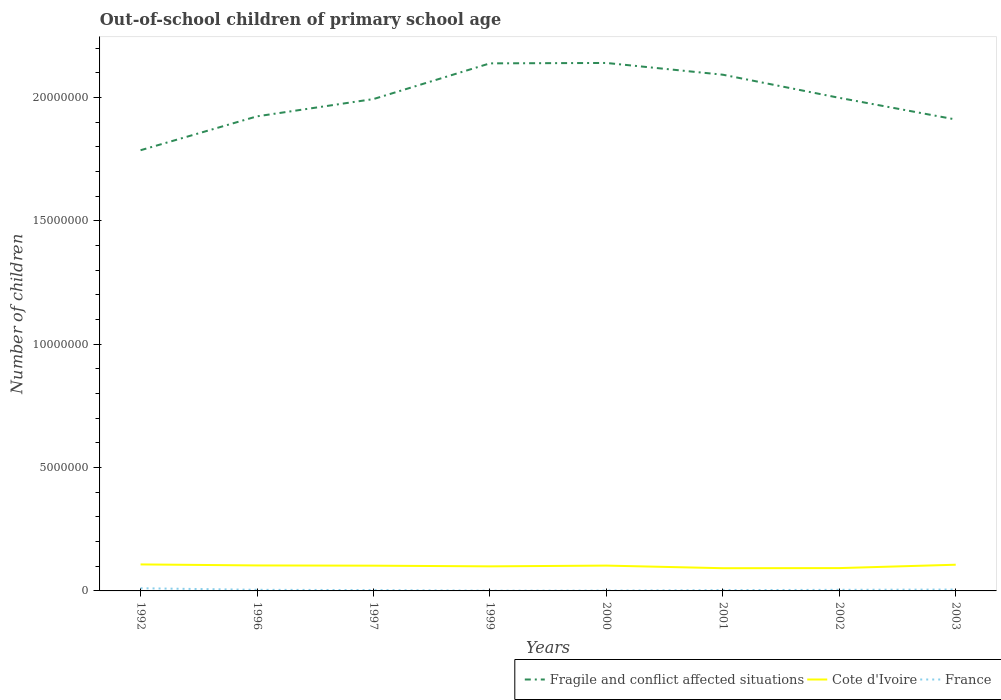How many different coloured lines are there?
Ensure brevity in your answer.  3. Across all years, what is the maximum number of out-of-school children in Cote d'Ivoire?
Offer a very short reply. 9.21e+05. What is the total number of out-of-school children in Cote d'Ivoire in the graph?
Keep it short and to the point. 7.85e+04. What is the difference between the highest and the second highest number of out-of-school children in France?
Offer a very short reply. 9.80e+04. What is the difference between the highest and the lowest number of out-of-school children in Fragile and conflict affected situations?
Offer a terse response. 4. What is the difference between two consecutive major ticks on the Y-axis?
Offer a very short reply. 5.00e+06. Does the graph contain grids?
Your answer should be very brief. No. How many legend labels are there?
Your response must be concise. 3. How are the legend labels stacked?
Ensure brevity in your answer.  Horizontal. What is the title of the graph?
Offer a very short reply. Out-of-school children of primary school age. Does "Honduras" appear as one of the legend labels in the graph?
Give a very brief answer. No. What is the label or title of the X-axis?
Provide a succinct answer. Years. What is the label or title of the Y-axis?
Make the answer very short. Number of children. What is the Number of children in Fragile and conflict affected situations in 1992?
Provide a short and direct response. 1.79e+07. What is the Number of children of Cote d'Ivoire in 1992?
Offer a terse response. 1.07e+06. What is the Number of children of France in 1992?
Keep it short and to the point. 1.08e+05. What is the Number of children in Fragile and conflict affected situations in 1996?
Make the answer very short. 1.92e+07. What is the Number of children of Cote d'Ivoire in 1996?
Ensure brevity in your answer.  1.03e+06. What is the Number of children in France in 1996?
Offer a terse response. 4.55e+04. What is the Number of children in Fragile and conflict affected situations in 1997?
Your response must be concise. 1.99e+07. What is the Number of children of Cote d'Ivoire in 1997?
Offer a very short reply. 1.02e+06. What is the Number of children of France in 1997?
Your response must be concise. 3.36e+04. What is the Number of children of Fragile and conflict affected situations in 1999?
Provide a succinct answer. 2.14e+07. What is the Number of children in Cote d'Ivoire in 1999?
Give a very brief answer. 9.95e+05. What is the Number of children of France in 1999?
Your response must be concise. 1.02e+04. What is the Number of children in Fragile and conflict affected situations in 2000?
Give a very brief answer. 2.14e+07. What is the Number of children of Cote d'Ivoire in 2000?
Offer a very short reply. 1.03e+06. What is the Number of children of France in 2000?
Your answer should be compact. 1.40e+04. What is the Number of children of Fragile and conflict affected situations in 2001?
Provide a short and direct response. 2.09e+07. What is the Number of children of Cote d'Ivoire in 2001?
Keep it short and to the point. 9.21e+05. What is the Number of children of France in 2001?
Offer a very short reply. 3.23e+04. What is the Number of children in Fragile and conflict affected situations in 2002?
Provide a short and direct response. 2.00e+07. What is the Number of children in Cote d'Ivoire in 2002?
Your answer should be very brief. 9.25e+05. What is the Number of children in France in 2002?
Your response must be concise. 4.47e+04. What is the Number of children of Fragile and conflict affected situations in 2003?
Make the answer very short. 1.91e+07. What is the Number of children in Cote d'Ivoire in 2003?
Your answer should be very brief. 1.06e+06. What is the Number of children in France in 2003?
Ensure brevity in your answer.  5.64e+04. Across all years, what is the maximum Number of children of Fragile and conflict affected situations?
Offer a very short reply. 2.14e+07. Across all years, what is the maximum Number of children in Cote d'Ivoire?
Make the answer very short. 1.07e+06. Across all years, what is the maximum Number of children in France?
Provide a succinct answer. 1.08e+05. Across all years, what is the minimum Number of children of Fragile and conflict affected situations?
Your response must be concise. 1.79e+07. Across all years, what is the minimum Number of children in Cote d'Ivoire?
Your response must be concise. 9.21e+05. Across all years, what is the minimum Number of children of France?
Keep it short and to the point. 1.02e+04. What is the total Number of children of Fragile and conflict affected situations in the graph?
Provide a short and direct response. 1.60e+08. What is the total Number of children in Cote d'Ivoire in the graph?
Your response must be concise. 8.06e+06. What is the total Number of children of France in the graph?
Make the answer very short. 3.45e+05. What is the difference between the Number of children of Fragile and conflict affected situations in 1992 and that in 1996?
Your response must be concise. -1.37e+06. What is the difference between the Number of children of Cote d'Ivoire in 1992 and that in 1996?
Your answer should be very brief. 4.14e+04. What is the difference between the Number of children of France in 1992 and that in 1996?
Provide a succinct answer. 6.26e+04. What is the difference between the Number of children of Fragile and conflict affected situations in 1992 and that in 1997?
Keep it short and to the point. -2.07e+06. What is the difference between the Number of children of Cote d'Ivoire in 1992 and that in 1997?
Offer a very short reply. 5.05e+04. What is the difference between the Number of children of France in 1992 and that in 1997?
Keep it short and to the point. 7.45e+04. What is the difference between the Number of children in Fragile and conflict affected situations in 1992 and that in 1999?
Keep it short and to the point. -3.52e+06. What is the difference between the Number of children of Cote d'Ivoire in 1992 and that in 1999?
Make the answer very short. 7.85e+04. What is the difference between the Number of children of France in 1992 and that in 1999?
Provide a short and direct response. 9.80e+04. What is the difference between the Number of children of Fragile and conflict affected situations in 1992 and that in 2000?
Offer a very short reply. -3.54e+06. What is the difference between the Number of children in Cote d'Ivoire in 1992 and that in 2000?
Provide a short and direct response. 4.74e+04. What is the difference between the Number of children of France in 1992 and that in 2000?
Provide a succinct answer. 9.42e+04. What is the difference between the Number of children in Fragile and conflict affected situations in 1992 and that in 2001?
Provide a short and direct response. -3.06e+06. What is the difference between the Number of children in Cote d'Ivoire in 1992 and that in 2001?
Keep it short and to the point. 1.53e+05. What is the difference between the Number of children in France in 1992 and that in 2001?
Provide a succinct answer. 7.59e+04. What is the difference between the Number of children in Fragile and conflict affected situations in 1992 and that in 2002?
Ensure brevity in your answer.  -2.12e+06. What is the difference between the Number of children in Cote d'Ivoire in 1992 and that in 2002?
Your answer should be compact. 1.49e+05. What is the difference between the Number of children in France in 1992 and that in 2002?
Provide a succinct answer. 6.35e+04. What is the difference between the Number of children in Fragile and conflict affected situations in 1992 and that in 2003?
Make the answer very short. -1.25e+06. What is the difference between the Number of children in Cote d'Ivoire in 1992 and that in 2003?
Your answer should be very brief. 1.18e+04. What is the difference between the Number of children of France in 1992 and that in 2003?
Provide a succinct answer. 5.18e+04. What is the difference between the Number of children of Fragile and conflict affected situations in 1996 and that in 1997?
Ensure brevity in your answer.  -7.00e+05. What is the difference between the Number of children in Cote d'Ivoire in 1996 and that in 1997?
Offer a very short reply. 9096. What is the difference between the Number of children of France in 1996 and that in 1997?
Give a very brief answer. 1.19e+04. What is the difference between the Number of children of Fragile and conflict affected situations in 1996 and that in 1999?
Keep it short and to the point. -2.15e+06. What is the difference between the Number of children in Cote d'Ivoire in 1996 and that in 1999?
Offer a terse response. 3.71e+04. What is the difference between the Number of children of France in 1996 and that in 1999?
Ensure brevity in your answer.  3.53e+04. What is the difference between the Number of children in Fragile and conflict affected situations in 1996 and that in 2000?
Your answer should be very brief. -2.16e+06. What is the difference between the Number of children in Cote d'Ivoire in 1996 and that in 2000?
Make the answer very short. 6006. What is the difference between the Number of children of France in 1996 and that in 2000?
Provide a succinct answer. 3.16e+04. What is the difference between the Number of children in Fragile and conflict affected situations in 1996 and that in 2001?
Ensure brevity in your answer.  -1.69e+06. What is the difference between the Number of children in Cote d'Ivoire in 1996 and that in 2001?
Keep it short and to the point. 1.12e+05. What is the difference between the Number of children of France in 1996 and that in 2001?
Provide a succinct answer. 1.33e+04. What is the difference between the Number of children of Fragile and conflict affected situations in 1996 and that in 2002?
Offer a terse response. -7.50e+05. What is the difference between the Number of children of Cote d'Ivoire in 1996 and that in 2002?
Offer a very short reply. 1.08e+05. What is the difference between the Number of children in France in 1996 and that in 2002?
Ensure brevity in your answer.  838. What is the difference between the Number of children in Fragile and conflict affected situations in 1996 and that in 2003?
Give a very brief answer. 1.28e+05. What is the difference between the Number of children in Cote d'Ivoire in 1996 and that in 2003?
Your answer should be very brief. -2.96e+04. What is the difference between the Number of children of France in 1996 and that in 2003?
Your answer should be compact. -1.08e+04. What is the difference between the Number of children in Fragile and conflict affected situations in 1997 and that in 1999?
Provide a succinct answer. -1.45e+06. What is the difference between the Number of children in Cote d'Ivoire in 1997 and that in 1999?
Keep it short and to the point. 2.80e+04. What is the difference between the Number of children of France in 1997 and that in 1999?
Keep it short and to the point. 2.35e+04. What is the difference between the Number of children of Fragile and conflict affected situations in 1997 and that in 2000?
Ensure brevity in your answer.  -1.46e+06. What is the difference between the Number of children of Cote d'Ivoire in 1997 and that in 2000?
Make the answer very short. -3090. What is the difference between the Number of children in France in 1997 and that in 2000?
Your answer should be very brief. 1.97e+04. What is the difference between the Number of children of Fragile and conflict affected situations in 1997 and that in 2001?
Provide a succinct answer. -9.87e+05. What is the difference between the Number of children in Cote d'Ivoire in 1997 and that in 2001?
Give a very brief answer. 1.03e+05. What is the difference between the Number of children in France in 1997 and that in 2001?
Give a very brief answer. 1379. What is the difference between the Number of children of Fragile and conflict affected situations in 1997 and that in 2002?
Make the answer very short. -4.94e+04. What is the difference between the Number of children in Cote d'Ivoire in 1997 and that in 2002?
Offer a very short reply. 9.86e+04. What is the difference between the Number of children in France in 1997 and that in 2002?
Make the answer very short. -1.10e+04. What is the difference between the Number of children in Fragile and conflict affected situations in 1997 and that in 2003?
Your answer should be compact. 8.28e+05. What is the difference between the Number of children of Cote d'Ivoire in 1997 and that in 2003?
Your response must be concise. -3.87e+04. What is the difference between the Number of children of France in 1997 and that in 2003?
Make the answer very short. -2.27e+04. What is the difference between the Number of children in Fragile and conflict affected situations in 1999 and that in 2000?
Offer a very short reply. -1.60e+04. What is the difference between the Number of children of Cote d'Ivoire in 1999 and that in 2000?
Give a very brief answer. -3.11e+04. What is the difference between the Number of children of France in 1999 and that in 2000?
Make the answer very short. -3778. What is the difference between the Number of children in Fragile and conflict affected situations in 1999 and that in 2001?
Make the answer very short. 4.60e+05. What is the difference between the Number of children of Cote d'Ivoire in 1999 and that in 2001?
Keep it short and to the point. 7.49e+04. What is the difference between the Number of children in France in 1999 and that in 2001?
Provide a short and direct response. -2.21e+04. What is the difference between the Number of children in Fragile and conflict affected situations in 1999 and that in 2002?
Your answer should be very brief. 1.40e+06. What is the difference between the Number of children in Cote d'Ivoire in 1999 and that in 2002?
Ensure brevity in your answer.  7.06e+04. What is the difference between the Number of children in France in 1999 and that in 2002?
Offer a very short reply. -3.45e+04. What is the difference between the Number of children in Fragile and conflict affected situations in 1999 and that in 2003?
Offer a very short reply. 2.28e+06. What is the difference between the Number of children in Cote d'Ivoire in 1999 and that in 2003?
Make the answer very short. -6.67e+04. What is the difference between the Number of children in France in 1999 and that in 2003?
Keep it short and to the point. -4.62e+04. What is the difference between the Number of children of Fragile and conflict affected situations in 2000 and that in 2001?
Provide a short and direct response. 4.76e+05. What is the difference between the Number of children in Cote d'Ivoire in 2000 and that in 2001?
Offer a very short reply. 1.06e+05. What is the difference between the Number of children in France in 2000 and that in 2001?
Your answer should be compact. -1.83e+04. What is the difference between the Number of children in Fragile and conflict affected situations in 2000 and that in 2002?
Provide a succinct answer. 1.41e+06. What is the difference between the Number of children in Cote d'Ivoire in 2000 and that in 2002?
Offer a very short reply. 1.02e+05. What is the difference between the Number of children of France in 2000 and that in 2002?
Offer a terse response. -3.07e+04. What is the difference between the Number of children in Fragile and conflict affected situations in 2000 and that in 2003?
Keep it short and to the point. 2.29e+06. What is the difference between the Number of children of Cote d'Ivoire in 2000 and that in 2003?
Make the answer very short. -3.56e+04. What is the difference between the Number of children of France in 2000 and that in 2003?
Offer a terse response. -4.24e+04. What is the difference between the Number of children in Fragile and conflict affected situations in 2001 and that in 2002?
Your response must be concise. 9.38e+05. What is the difference between the Number of children in Cote d'Ivoire in 2001 and that in 2002?
Your response must be concise. -4265. What is the difference between the Number of children of France in 2001 and that in 2002?
Provide a short and direct response. -1.24e+04. What is the difference between the Number of children in Fragile and conflict affected situations in 2001 and that in 2003?
Make the answer very short. 1.82e+06. What is the difference between the Number of children of Cote d'Ivoire in 2001 and that in 2003?
Your answer should be very brief. -1.42e+05. What is the difference between the Number of children in France in 2001 and that in 2003?
Provide a succinct answer. -2.41e+04. What is the difference between the Number of children in Fragile and conflict affected situations in 2002 and that in 2003?
Give a very brief answer. 8.78e+05. What is the difference between the Number of children of Cote d'Ivoire in 2002 and that in 2003?
Offer a terse response. -1.37e+05. What is the difference between the Number of children in France in 2002 and that in 2003?
Keep it short and to the point. -1.17e+04. What is the difference between the Number of children of Fragile and conflict affected situations in 1992 and the Number of children of Cote d'Ivoire in 1996?
Offer a terse response. 1.68e+07. What is the difference between the Number of children of Fragile and conflict affected situations in 1992 and the Number of children of France in 1996?
Offer a very short reply. 1.78e+07. What is the difference between the Number of children of Cote d'Ivoire in 1992 and the Number of children of France in 1996?
Provide a short and direct response. 1.03e+06. What is the difference between the Number of children in Fragile and conflict affected situations in 1992 and the Number of children in Cote d'Ivoire in 1997?
Give a very brief answer. 1.68e+07. What is the difference between the Number of children in Fragile and conflict affected situations in 1992 and the Number of children in France in 1997?
Your response must be concise. 1.78e+07. What is the difference between the Number of children of Cote d'Ivoire in 1992 and the Number of children of France in 1997?
Your answer should be very brief. 1.04e+06. What is the difference between the Number of children in Fragile and conflict affected situations in 1992 and the Number of children in Cote d'Ivoire in 1999?
Provide a succinct answer. 1.69e+07. What is the difference between the Number of children of Fragile and conflict affected situations in 1992 and the Number of children of France in 1999?
Provide a succinct answer. 1.79e+07. What is the difference between the Number of children of Cote d'Ivoire in 1992 and the Number of children of France in 1999?
Ensure brevity in your answer.  1.06e+06. What is the difference between the Number of children of Fragile and conflict affected situations in 1992 and the Number of children of Cote d'Ivoire in 2000?
Offer a terse response. 1.68e+07. What is the difference between the Number of children of Fragile and conflict affected situations in 1992 and the Number of children of France in 2000?
Provide a succinct answer. 1.78e+07. What is the difference between the Number of children in Cote d'Ivoire in 1992 and the Number of children in France in 2000?
Keep it short and to the point. 1.06e+06. What is the difference between the Number of children of Fragile and conflict affected situations in 1992 and the Number of children of Cote d'Ivoire in 2001?
Your answer should be compact. 1.69e+07. What is the difference between the Number of children in Fragile and conflict affected situations in 1992 and the Number of children in France in 2001?
Provide a short and direct response. 1.78e+07. What is the difference between the Number of children in Cote d'Ivoire in 1992 and the Number of children in France in 2001?
Ensure brevity in your answer.  1.04e+06. What is the difference between the Number of children of Fragile and conflict affected situations in 1992 and the Number of children of Cote d'Ivoire in 2002?
Provide a short and direct response. 1.69e+07. What is the difference between the Number of children of Fragile and conflict affected situations in 1992 and the Number of children of France in 2002?
Provide a short and direct response. 1.78e+07. What is the difference between the Number of children in Cote d'Ivoire in 1992 and the Number of children in France in 2002?
Offer a terse response. 1.03e+06. What is the difference between the Number of children in Fragile and conflict affected situations in 1992 and the Number of children in Cote d'Ivoire in 2003?
Provide a short and direct response. 1.68e+07. What is the difference between the Number of children in Fragile and conflict affected situations in 1992 and the Number of children in France in 2003?
Keep it short and to the point. 1.78e+07. What is the difference between the Number of children in Cote d'Ivoire in 1992 and the Number of children in France in 2003?
Give a very brief answer. 1.02e+06. What is the difference between the Number of children in Fragile and conflict affected situations in 1996 and the Number of children in Cote d'Ivoire in 1997?
Your answer should be compact. 1.82e+07. What is the difference between the Number of children in Fragile and conflict affected situations in 1996 and the Number of children in France in 1997?
Keep it short and to the point. 1.92e+07. What is the difference between the Number of children of Cote d'Ivoire in 1996 and the Number of children of France in 1997?
Ensure brevity in your answer.  9.99e+05. What is the difference between the Number of children in Fragile and conflict affected situations in 1996 and the Number of children in Cote d'Ivoire in 1999?
Ensure brevity in your answer.  1.82e+07. What is the difference between the Number of children of Fragile and conflict affected situations in 1996 and the Number of children of France in 1999?
Make the answer very short. 1.92e+07. What is the difference between the Number of children of Cote d'Ivoire in 1996 and the Number of children of France in 1999?
Ensure brevity in your answer.  1.02e+06. What is the difference between the Number of children in Fragile and conflict affected situations in 1996 and the Number of children in Cote d'Ivoire in 2000?
Make the answer very short. 1.82e+07. What is the difference between the Number of children in Fragile and conflict affected situations in 1996 and the Number of children in France in 2000?
Provide a short and direct response. 1.92e+07. What is the difference between the Number of children in Cote d'Ivoire in 1996 and the Number of children in France in 2000?
Make the answer very short. 1.02e+06. What is the difference between the Number of children of Fragile and conflict affected situations in 1996 and the Number of children of Cote d'Ivoire in 2001?
Provide a succinct answer. 1.83e+07. What is the difference between the Number of children in Fragile and conflict affected situations in 1996 and the Number of children in France in 2001?
Provide a succinct answer. 1.92e+07. What is the difference between the Number of children in Cote d'Ivoire in 1996 and the Number of children in France in 2001?
Make the answer very short. 1.00e+06. What is the difference between the Number of children in Fragile and conflict affected situations in 1996 and the Number of children in Cote d'Ivoire in 2002?
Your answer should be compact. 1.83e+07. What is the difference between the Number of children of Fragile and conflict affected situations in 1996 and the Number of children of France in 2002?
Ensure brevity in your answer.  1.92e+07. What is the difference between the Number of children of Cote d'Ivoire in 1996 and the Number of children of France in 2002?
Ensure brevity in your answer.  9.88e+05. What is the difference between the Number of children in Fragile and conflict affected situations in 1996 and the Number of children in Cote d'Ivoire in 2003?
Offer a very short reply. 1.82e+07. What is the difference between the Number of children of Fragile and conflict affected situations in 1996 and the Number of children of France in 2003?
Offer a terse response. 1.92e+07. What is the difference between the Number of children in Cote d'Ivoire in 1996 and the Number of children in France in 2003?
Your answer should be very brief. 9.76e+05. What is the difference between the Number of children in Fragile and conflict affected situations in 1997 and the Number of children in Cote d'Ivoire in 1999?
Offer a terse response. 1.89e+07. What is the difference between the Number of children in Fragile and conflict affected situations in 1997 and the Number of children in France in 1999?
Your answer should be compact. 1.99e+07. What is the difference between the Number of children in Cote d'Ivoire in 1997 and the Number of children in France in 1999?
Your response must be concise. 1.01e+06. What is the difference between the Number of children of Fragile and conflict affected situations in 1997 and the Number of children of Cote d'Ivoire in 2000?
Provide a succinct answer. 1.89e+07. What is the difference between the Number of children in Fragile and conflict affected situations in 1997 and the Number of children in France in 2000?
Provide a short and direct response. 1.99e+07. What is the difference between the Number of children of Cote d'Ivoire in 1997 and the Number of children of France in 2000?
Keep it short and to the point. 1.01e+06. What is the difference between the Number of children in Fragile and conflict affected situations in 1997 and the Number of children in Cote d'Ivoire in 2001?
Provide a short and direct response. 1.90e+07. What is the difference between the Number of children in Fragile and conflict affected situations in 1997 and the Number of children in France in 2001?
Provide a short and direct response. 1.99e+07. What is the difference between the Number of children of Cote d'Ivoire in 1997 and the Number of children of France in 2001?
Offer a very short reply. 9.91e+05. What is the difference between the Number of children of Fragile and conflict affected situations in 1997 and the Number of children of Cote d'Ivoire in 2002?
Offer a terse response. 1.90e+07. What is the difference between the Number of children of Fragile and conflict affected situations in 1997 and the Number of children of France in 2002?
Ensure brevity in your answer.  1.99e+07. What is the difference between the Number of children of Cote d'Ivoire in 1997 and the Number of children of France in 2002?
Offer a very short reply. 9.79e+05. What is the difference between the Number of children of Fragile and conflict affected situations in 1997 and the Number of children of Cote d'Ivoire in 2003?
Your answer should be compact. 1.89e+07. What is the difference between the Number of children of Fragile and conflict affected situations in 1997 and the Number of children of France in 2003?
Your answer should be compact. 1.99e+07. What is the difference between the Number of children in Cote d'Ivoire in 1997 and the Number of children in France in 2003?
Offer a very short reply. 9.67e+05. What is the difference between the Number of children of Fragile and conflict affected situations in 1999 and the Number of children of Cote d'Ivoire in 2000?
Provide a short and direct response. 2.04e+07. What is the difference between the Number of children of Fragile and conflict affected situations in 1999 and the Number of children of France in 2000?
Keep it short and to the point. 2.14e+07. What is the difference between the Number of children of Cote d'Ivoire in 1999 and the Number of children of France in 2000?
Keep it short and to the point. 9.82e+05. What is the difference between the Number of children in Fragile and conflict affected situations in 1999 and the Number of children in Cote d'Ivoire in 2001?
Provide a succinct answer. 2.05e+07. What is the difference between the Number of children in Fragile and conflict affected situations in 1999 and the Number of children in France in 2001?
Offer a terse response. 2.13e+07. What is the difference between the Number of children in Cote d'Ivoire in 1999 and the Number of children in France in 2001?
Provide a succinct answer. 9.63e+05. What is the difference between the Number of children of Fragile and conflict affected situations in 1999 and the Number of children of Cote d'Ivoire in 2002?
Provide a short and direct response. 2.05e+07. What is the difference between the Number of children in Fragile and conflict affected situations in 1999 and the Number of children in France in 2002?
Your response must be concise. 2.13e+07. What is the difference between the Number of children of Cote d'Ivoire in 1999 and the Number of children of France in 2002?
Give a very brief answer. 9.51e+05. What is the difference between the Number of children in Fragile and conflict affected situations in 1999 and the Number of children in Cote d'Ivoire in 2003?
Provide a short and direct response. 2.03e+07. What is the difference between the Number of children of Fragile and conflict affected situations in 1999 and the Number of children of France in 2003?
Keep it short and to the point. 2.13e+07. What is the difference between the Number of children in Cote d'Ivoire in 1999 and the Number of children in France in 2003?
Your response must be concise. 9.39e+05. What is the difference between the Number of children of Fragile and conflict affected situations in 2000 and the Number of children of Cote d'Ivoire in 2001?
Your answer should be compact. 2.05e+07. What is the difference between the Number of children in Fragile and conflict affected situations in 2000 and the Number of children in France in 2001?
Provide a short and direct response. 2.14e+07. What is the difference between the Number of children of Cote d'Ivoire in 2000 and the Number of children of France in 2001?
Offer a very short reply. 9.94e+05. What is the difference between the Number of children in Fragile and conflict affected situations in 2000 and the Number of children in Cote d'Ivoire in 2002?
Keep it short and to the point. 2.05e+07. What is the difference between the Number of children of Fragile and conflict affected situations in 2000 and the Number of children of France in 2002?
Provide a succinct answer. 2.14e+07. What is the difference between the Number of children of Cote d'Ivoire in 2000 and the Number of children of France in 2002?
Make the answer very short. 9.82e+05. What is the difference between the Number of children of Fragile and conflict affected situations in 2000 and the Number of children of Cote d'Ivoire in 2003?
Your answer should be compact. 2.03e+07. What is the difference between the Number of children in Fragile and conflict affected situations in 2000 and the Number of children in France in 2003?
Your response must be concise. 2.13e+07. What is the difference between the Number of children of Cote d'Ivoire in 2000 and the Number of children of France in 2003?
Give a very brief answer. 9.70e+05. What is the difference between the Number of children in Fragile and conflict affected situations in 2001 and the Number of children in Cote d'Ivoire in 2002?
Provide a succinct answer. 2.00e+07. What is the difference between the Number of children of Fragile and conflict affected situations in 2001 and the Number of children of France in 2002?
Your response must be concise. 2.09e+07. What is the difference between the Number of children of Cote d'Ivoire in 2001 and the Number of children of France in 2002?
Offer a terse response. 8.76e+05. What is the difference between the Number of children of Fragile and conflict affected situations in 2001 and the Number of children of Cote d'Ivoire in 2003?
Provide a short and direct response. 1.99e+07. What is the difference between the Number of children in Fragile and conflict affected situations in 2001 and the Number of children in France in 2003?
Offer a very short reply. 2.09e+07. What is the difference between the Number of children in Cote d'Ivoire in 2001 and the Number of children in France in 2003?
Give a very brief answer. 8.64e+05. What is the difference between the Number of children in Fragile and conflict affected situations in 2002 and the Number of children in Cote d'Ivoire in 2003?
Your response must be concise. 1.89e+07. What is the difference between the Number of children in Fragile and conflict affected situations in 2002 and the Number of children in France in 2003?
Keep it short and to the point. 1.99e+07. What is the difference between the Number of children of Cote d'Ivoire in 2002 and the Number of children of France in 2003?
Make the answer very short. 8.69e+05. What is the average Number of children in Fragile and conflict affected situations per year?
Make the answer very short. 2.00e+07. What is the average Number of children in Cote d'Ivoire per year?
Your answer should be compact. 1.01e+06. What is the average Number of children of France per year?
Ensure brevity in your answer.  4.31e+04. In the year 1992, what is the difference between the Number of children in Fragile and conflict affected situations and Number of children in Cote d'Ivoire?
Provide a succinct answer. 1.68e+07. In the year 1992, what is the difference between the Number of children of Fragile and conflict affected situations and Number of children of France?
Ensure brevity in your answer.  1.78e+07. In the year 1992, what is the difference between the Number of children of Cote d'Ivoire and Number of children of France?
Offer a very short reply. 9.66e+05. In the year 1996, what is the difference between the Number of children in Fragile and conflict affected situations and Number of children in Cote d'Ivoire?
Give a very brief answer. 1.82e+07. In the year 1996, what is the difference between the Number of children in Fragile and conflict affected situations and Number of children in France?
Your answer should be very brief. 1.92e+07. In the year 1996, what is the difference between the Number of children in Cote d'Ivoire and Number of children in France?
Your answer should be very brief. 9.87e+05. In the year 1997, what is the difference between the Number of children of Fragile and conflict affected situations and Number of children of Cote d'Ivoire?
Give a very brief answer. 1.89e+07. In the year 1997, what is the difference between the Number of children of Fragile and conflict affected situations and Number of children of France?
Give a very brief answer. 1.99e+07. In the year 1997, what is the difference between the Number of children of Cote d'Ivoire and Number of children of France?
Your answer should be compact. 9.90e+05. In the year 1999, what is the difference between the Number of children in Fragile and conflict affected situations and Number of children in Cote d'Ivoire?
Keep it short and to the point. 2.04e+07. In the year 1999, what is the difference between the Number of children in Fragile and conflict affected situations and Number of children in France?
Keep it short and to the point. 2.14e+07. In the year 1999, what is the difference between the Number of children of Cote d'Ivoire and Number of children of France?
Your answer should be compact. 9.85e+05. In the year 2000, what is the difference between the Number of children in Fragile and conflict affected situations and Number of children in Cote d'Ivoire?
Provide a short and direct response. 2.04e+07. In the year 2000, what is the difference between the Number of children of Fragile and conflict affected situations and Number of children of France?
Your response must be concise. 2.14e+07. In the year 2000, what is the difference between the Number of children of Cote d'Ivoire and Number of children of France?
Your answer should be very brief. 1.01e+06. In the year 2001, what is the difference between the Number of children in Fragile and conflict affected situations and Number of children in Cote d'Ivoire?
Ensure brevity in your answer.  2.00e+07. In the year 2001, what is the difference between the Number of children of Fragile and conflict affected situations and Number of children of France?
Make the answer very short. 2.09e+07. In the year 2001, what is the difference between the Number of children of Cote d'Ivoire and Number of children of France?
Your answer should be very brief. 8.88e+05. In the year 2002, what is the difference between the Number of children in Fragile and conflict affected situations and Number of children in Cote d'Ivoire?
Your answer should be compact. 1.91e+07. In the year 2002, what is the difference between the Number of children in Fragile and conflict affected situations and Number of children in France?
Give a very brief answer. 1.99e+07. In the year 2002, what is the difference between the Number of children in Cote d'Ivoire and Number of children in France?
Make the answer very short. 8.80e+05. In the year 2003, what is the difference between the Number of children of Fragile and conflict affected situations and Number of children of Cote d'Ivoire?
Provide a short and direct response. 1.80e+07. In the year 2003, what is the difference between the Number of children of Fragile and conflict affected situations and Number of children of France?
Your answer should be compact. 1.90e+07. In the year 2003, what is the difference between the Number of children in Cote d'Ivoire and Number of children in France?
Offer a terse response. 1.01e+06. What is the ratio of the Number of children in Cote d'Ivoire in 1992 to that in 1996?
Your response must be concise. 1.04. What is the ratio of the Number of children in France in 1992 to that in 1996?
Make the answer very short. 2.38. What is the ratio of the Number of children in Fragile and conflict affected situations in 1992 to that in 1997?
Provide a short and direct response. 0.9. What is the ratio of the Number of children in Cote d'Ivoire in 1992 to that in 1997?
Keep it short and to the point. 1.05. What is the ratio of the Number of children of France in 1992 to that in 1997?
Offer a terse response. 3.22. What is the ratio of the Number of children of Fragile and conflict affected situations in 1992 to that in 1999?
Offer a very short reply. 0.84. What is the ratio of the Number of children of Cote d'Ivoire in 1992 to that in 1999?
Ensure brevity in your answer.  1.08. What is the ratio of the Number of children in France in 1992 to that in 1999?
Offer a terse response. 10.63. What is the ratio of the Number of children of Fragile and conflict affected situations in 1992 to that in 2000?
Ensure brevity in your answer.  0.83. What is the ratio of the Number of children of Cote d'Ivoire in 1992 to that in 2000?
Ensure brevity in your answer.  1.05. What is the ratio of the Number of children of France in 1992 to that in 2000?
Ensure brevity in your answer.  7.75. What is the ratio of the Number of children of Fragile and conflict affected situations in 1992 to that in 2001?
Your response must be concise. 0.85. What is the ratio of the Number of children in Cote d'Ivoire in 1992 to that in 2001?
Make the answer very short. 1.17. What is the ratio of the Number of children in France in 1992 to that in 2001?
Your answer should be compact. 3.35. What is the ratio of the Number of children of Fragile and conflict affected situations in 1992 to that in 2002?
Make the answer very short. 0.89. What is the ratio of the Number of children in Cote d'Ivoire in 1992 to that in 2002?
Give a very brief answer. 1.16. What is the ratio of the Number of children of France in 1992 to that in 2002?
Provide a short and direct response. 2.42. What is the ratio of the Number of children of Fragile and conflict affected situations in 1992 to that in 2003?
Give a very brief answer. 0.93. What is the ratio of the Number of children in Cote d'Ivoire in 1992 to that in 2003?
Offer a very short reply. 1.01. What is the ratio of the Number of children of France in 1992 to that in 2003?
Your answer should be compact. 1.92. What is the ratio of the Number of children of Fragile and conflict affected situations in 1996 to that in 1997?
Your answer should be compact. 0.96. What is the ratio of the Number of children of Cote d'Ivoire in 1996 to that in 1997?
Keep it short and to the point. 1.01. What is the ratio of the Number of children of France in 1996 to that in 1997?
Make the answer very short. 1.35. What is the ratio of the Number of children of Fragile and conflict affected situations in 1996 to that in 1999?
Provide a short and direct response. 0.9. What is the ratio of the Number of children in Cote d'Ivoire in 1996 to that in 1999?
Ensure brevity in your answer.  1.04. What is the ratio of the Number of children in France in 1996 to that in 1999?
Ensure brevity in your answer.  4.47. What is the ratio of the Number of children in Fragile and conflict affected situations in 1996 to that in 2000?
Your answer should be compact. 0.9. What is the ratio of the Number of children of Cote d'Ivoire in 1996 to that in 2000?
Your answer should be very brief. 1.01. What is the ratio of the Number of children in France in 1996 to that in 2000?
Offer a terse response. 3.26. What is the ratio of the Number of children of Fragile and conflict affected situations in 1996 to that in 2001?
Make the answer very short. 0.92. What is the ratio of the Number of children of Cote d'Ivoire in 1996 to that in 2001?
Make the answer very short. 1.12. What is the ratio of the Number of children in France in 1996 to that in 2001?
Offer a terse response. 1.41. What is the ratio of the Number of children of Fragile and conflict affected situations in 1996 to that in 2002?
Ensure brevity in your answer.  0.96. What is the ratio of the Number of children in Cote d'Ivoire in 1996 to that in 2002?
Give a very brief answer. 1.12. What is the ratio of the Number of children in France in 1996 to that in 2002?
Make the answer very short. 1.02. What is the ratio of the Number of children of Cote d'Ivoire in 1996 to that in 2003?
Provide a short and direct response. 0.97. What is the ratio of the Number of children in France in 1996 to that in 2003?
Ensure brevity in your answer.  0.81. What is the ratio of the Number of children of Fragile and conflict affected situations in 1997 to that in 1999?
Provide a short and direct response. 0.93. What is the ratio of the Number of children in Cote d'Ivoire in 1997 to that in 1999?
Offer a terse response. 1.03. What is the ratio of the Number of children of France in 1997 to that in 1999?
Provide a short and direct response. 3.3. What is the ratio of the Number of children of Fragile and conflict affected situations in 1997 to that in 2000?
Offer a terse response. 0.93. What is the ratio of the Number of children of Cote d'Ivoire in 1997 to that in 2000?
Provide a short and direct response. 1. What is the ratio of the Number of children in France in 1997 to that in 2000?
Make the answer very short. 2.41. What is the ratio of the Number of children in Fragile and conflict affected situations in 1997 to that in 2001?
Provide a succinct answer. 0.95. What is the ratio of the Number of children in Cote d'Ivoire in 1997 to that in 2001?
Provide a short and direct response. 1.11. What is the ratio of the Number of children of France in 1997 to that in 2001?
Offer a terse response. 1.04. What is the ratio of the Number of children of Cote d'Ivoire in 1997 to that in 2002?
Offer a terse response. 1.11. What is the ratio of the Number of children of France in 1997 to that in 2002?
Give a very brief answer. 0.75. What is the ratio of the Number of children of Fragile and conflict affected situations in 1997 to that in 2003?
Your answer should be compact. 1.04. What is the ratio of the Number of children in Cote d'Ivoire in 1997 to that in 2003?
Make the answer very short. 0.96. What is the ratio of the Number of children of France in 1997 to that in 2003?
Give a very brief answer. 0.6. What is the ratio of the Number of children of Fragile and conflict affected situations in 1999 to that in 2000?
Ensure brevity in your answer.  1. What is the ratio of the Number of children in Cote d'Ivoire in 1999 to that in 2000?
Offer a very short reply. 0.97. What is the ratio of the Number of children in France in 1999 to that in 2000?
Your answer should be compact. 0.73. What is the ratio of the Number of children in Cote d'Ivoire in 1999 to that in 2001?
Your answer should be very brief. 1.08. What is the ratio of the Number of children of France in 1999 to that in 2001?
Provide a succinct answer. 0.32. What is the ratio of the Number of children in Fragile and conflict affected situations in 1999 to that in 2002?
Your answer should be compact. 1.07. What is the ratio of the Number of children in Cote d'Ivoire in 1999 to that in 2002?
Your answer should be very brief. 1.08. What is the ratio of the Number of children in France in 1999 to that in 2002?
Your answer should be very brief. 0.23. What is the ratio of the Number of children of Fragile and conflict affected situations in 1999 to that in 2003?
Make the answer very short. 1.12. What is the ratio of the Number of children of Cote d'Ivoire in 1999 to that in 2003?
Ensure brevity in your answer.  0.94. What is the ratio of the Number of children in France in 1999 to that in 2003?
Give a very brief answer. 0.18. What is the ratio of the Number of children in Fragile and conflict affected situations in 2000 to that in 2001?
Your answer should be compact. 1.02. What is the ratio of the Number of children of Cote d'Ivoire in 2000 to that in 2001?
Your response must be concise. 1.12. What is the ratio of the Number of children in France in 2000 to that in 2001?
Your answer should be very brief. 0.43. What is the ratio of the Number of children in Fragile and conflict affected situations in 2000 to that in 2002?
Give a very brief answer. 1.07. What is the ratio of the Number of children of Cote d'Ivoire in 2000 to that in 2002?
Your answer should be compact. 1.11. What is the ratio of the Number of children of France in 2000 to that in 2002?
Your response must be concise. 0.31. What is the ratio of the Number of children in Fragile and conflict affected situations in 2000 to that in 2003?
Make the answer very short. 1.12. What is the ratio of the Number of children of Cote d'Ivoire in 2000 to that in 2003?
Keep it short and to the point. 0.97. What is the ratio of the Number of children of France in 2000 to that in 2003?
Provide a succinct answer. 0.25. What is the ratio of the Number of children of Fragile and conflict affected situations in 2001 to that in 2002?
Provide a short and direct response. 1.05. What is the ratio of the Number of children in France in 2001 to that in 2002?
Ensure brevity in your answer.  0.72. What is the ratio of the Number of children of Fragile and conflict affected situations in 2001 to that in 2003?
Ensure brevity in your answer.  1.09. What is the ratio of the Number of children of Cote d'Ivoire in 2001 to that in 2003?
Provide a succinct answer. 0.87. What is the ratio of the Number of children in France in 2001 to that in 2003?
Give a very brief answer. 0.57. What is the ratio of the Number of children in Fragile and conflict affected situations in 2002 to that in 2003?
Give a very brief answer. 1.05. What is the ratio of the Number of children in Cote d'Ivoire in 2002 to that in 2003?
Keep it short and to the point. 0.87. What is the ratio of the Number of children of France in 2002 to that in 2003?
Ensure brevity in your answer.  0.79. What is the difference between the highest and the second highest Number of children of Fragile and conflict affected situations?
Make the answer very short. 1.60e+04. What is the difference between the highest and the second highest Number of children of Cote d'Ivoire?
Provide a succinct answer. 1.18e+04. What is the difference between the highest and the second highest Number of children in France?
Offer a terse response. 5.18e+04. What is the difference between the highest and the lowest Number of children of Fragile and conflict affected situations?
Provide a short and direct response. 3.54e+06. What is the difference between the highest and the lowest Number of children in Cote d'Ivoire?
Ensure brevity in your answer.  1.53e+05. What is the difference between the highest and the lowest Number of children in France?
Provide a short and direct response. 9.80e+04. 